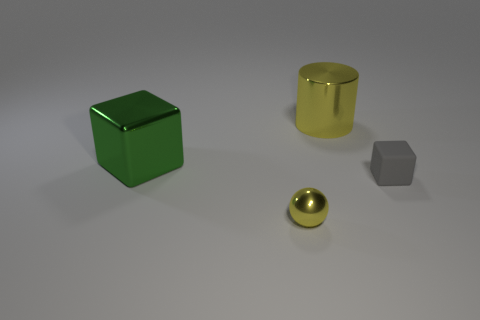The metallic cylinder that is the same color as the tiny sphere is what size?
Give a very brief answer. Large. What material is the object that is the same color as the shiny cylinder?
Your response must be concise. Metal. Are there any small blocks left of the yellow object on the left side of the shiny thing that is right of the tiny ball?
Provide a short and direct response. No. What number of matte things are small yellow balls or yellow blocks?
Give a very brief answer. 0. What number of other things are there of the same shape as the tiny metallic object?
Offer a very short reply. 0. Are there more green metal objects than tiny cyan blocks?
Offer a terse response. Yes. There is a yellow thing that is right of the shiny thing that is in front of the object that is right of the large yellow cylinder; how big is it?
Keep it short and to the point. Large. What size is the thing that is in front of the small rubber thing?
Give a very brief answer. Small. How many things are either blue cylinders or objects that are in front of the big green cube?
Make the answer very short. 2. What material is the tiny gray thing that is the same shape as the large green metal object?
Your answer should be compact. Rubber. 